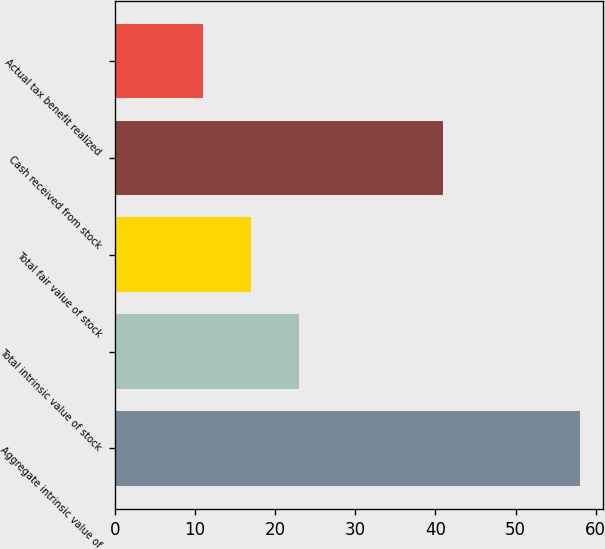Convert chart. <chart><loc_0><loc_0><loc_500><loc_500><bar_chart><fcel>Aggregate intrinsic value of<fcel>Total intrinsic value of stock<fcel>Total fair value of stock<fcel>Cash received from stock<fcel>Actual tax benefit realized<nl><fcel>58<fcel>23<fcel>17<fcel>41<fcel>11<nl></chart> 